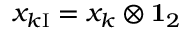<formula> <loc_0><loc_0><loc_500><loc_500>x _ { k I } = x _ { k } \otimes { 1 } _ { 2 }</formula> 